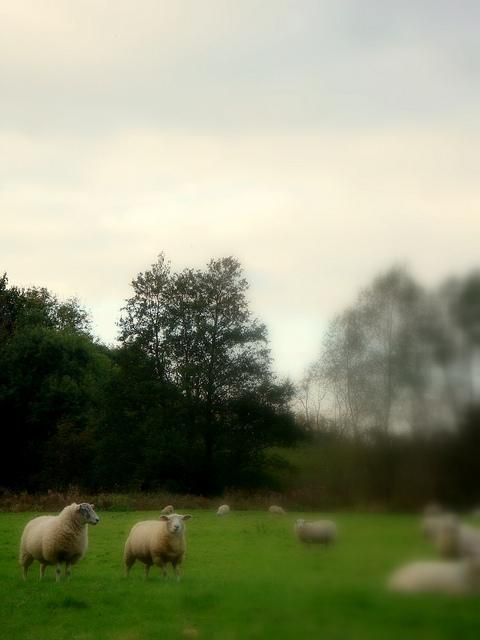What is the condition of the sky?

Choices:
A) clear skies
B) overcast
C) mostly sunny
D) mostly cloudy overcast 